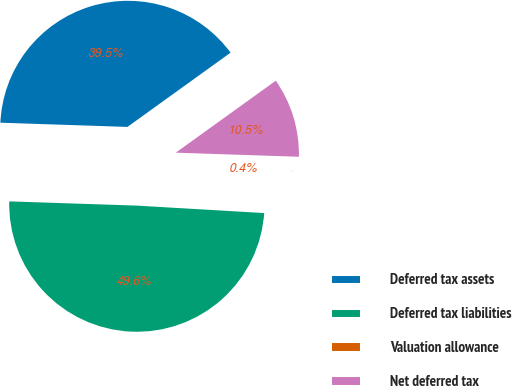Convert chart to OTSL. <chart><loc_0><loc_0><loc_500><loc_500><pie_chart><fcel>Deferred tax assets<fcel>Deferred tax liabilities<fcel>Valuation allowance<fcel>Net deferred tax<nl><fcel>39.54%<fcel>49.6%<fcel>0.4%<fcel>10.46%<nl></chart> 